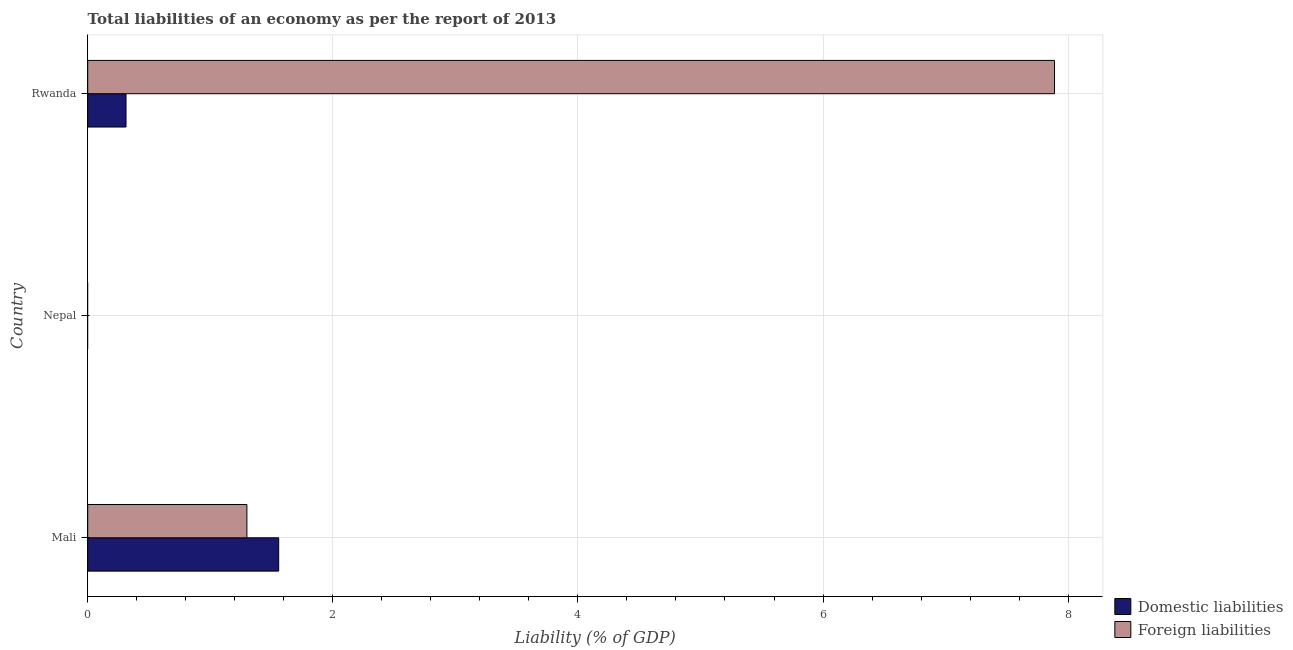How many different coloured bars are there?
Keep it short and to the point. 2. Are the number of bars per tick equal to the number of legend labels?
Offer a terse response. No. How many bars are there on the 2nd tick from the bottom?
Ensure brevity in your answer.  0. What is the label of the 3rd group of bars from the top?
Your response must be concise. Mali. In how many cases, is the number of bars for a given country not equal to the number of legend labels?
Offer a terse response. 1. What is the incurrence of domestic liabilities in Nepal?
Give a very brief answer. 0. Across all countries, what is the maximum incurrence of foreign liabilities?
Give a very brief answer. 7.89. In which country was the incurrence of foreign liabilities maximum?
Provide a short and direct response. Rwanda. What is the total incurrence of foreign liabilities in the graph?
Offer a terse response. 9.19. What is the difference between the incurrence of foreign liabilities in Mali and that in Rwanda?
Provide a short and direct response. -6.59. What is the difference between the incurrence of domestic liabilities in Rwanda and the incurrence of foreign liabilities in Nepal?
Keep it short and to the point. 0.31. What is the average incurrence of foreign liabilities per country?
Offer a very short reply. 3.06. What is the difference between the incurrence of domestic liabilities and incurrence of foreign liabilities in Rwanda?
Keep it short and to the point. -7.58. What is the ratio of the incurrence of domestic liabilities in Mali to that in Rwanda?
Give a very brief answer. 4.99. What is the difference between the highest and the lowest incurrence of foreign liabilities?
Offer a terse response. 7.89. In how many countries, is the incurrence of domestic liabilities greater than the average incurrence of domestic liabilities taken over all countries?
Your answer should be compact. 1. Is the sum of the incurrence of foreign liabilities in Mali and Rwanda greater than the maximum incurrence of domestic liabilities across all countries?
Ensure brevity in your answer.  Yes. How many bars are there?
Keep it short and to the point. 4. What is the difference between two consecutive major ticks on the X-axis?
Keep it short and to the point. 2. Does the graph contain any zero values?
Offer a terse response. Yes. Does the graph contain grids?
Provide a succinct answer. Yes. How many legend labels are there?
Your answer should be compact. 2. How are the legend labels stacked?
Make the answer very short. Vertical. What is the title of the graph?
Provide a short and direct response. Total liabilities of an economy as per the report of 2013. What is the label or title of the X-axis?
Your response must be concise. Liability (% of GDP). What is the Liability (% of GDP) of Domestic liabilities in Mali?
Offer a very short reply. 1.56. What is the Liability (% of GDP) in Foreign liabilities in Mali?
Provide a succinct answer. 1.3. What is the Liability (% of GDP) of Domestic liabilities in Nepal?
Your answer should be very brief. 0. What is the Liability (% of GDP) in Foreign liabilities in Nepal?
Keep it short and to the point. 0. What is the Liability (% of GDP) of Domestic liabilities in Rwanda?
Your response must be concise. 0.31. What is the Liability (% of GDP) of Foreign liabilities in Rwanda?
Your answer should be compact. 7.89. Across all countries, what is the maximum Liability (% of GDP) of Domestic liabilities?
Give a very brief answer. 1.56. Across all countries, what is the maximum Liability (% of GDP) of Foreign liabilities?
Keep it short and to the point. 7.89. Across all countries, what is the minimum Liability (% of GDP) of Domestic liabilities?
Make the answer very short. 0. What is the total Liability (% of GDP) of Domestic liabilities in the graph?
Give a very brief answer. 1.87. What is the total Liability (% of GDP) of Foreign liabilities in the graph?
Keep it short and to the point. 9.19. What is the difference between the Liability (% of GDP) of Domestic liabilities in Mali and that in Rwanda?
Offer a very short reply. 1.25. What is the difference between the Liability (% of GDP) of Foreign liabilities in Mali and that in Rwanda?
Provide a short and direct response. -6.59. What is the difference between the Liability (% of GDP) in Domestic liabilities in Mali and the Liability (% of GDP) in Foreign liabilities in Rwanda?
Your response must be concise. -6.33. What is the average Liability (% of GDP) of Domestic liabilities per country?
Your answer should be very brief. 0.62. What is the average Liability (% of GDP) in Foreign liabilities per country?
Provide a short and direct response. 3.06. What is the difference between the Liability (% of GDP) in Domestic liabilities and Liability (% of GDP) in Foreign liabilities in Mali?
Provide a short and direct response. 0.26. What is the difference between the Liability (% of GDP) of Domestic liabilities and Liability (% of GDP) of Foreign liabilities in Rwanda?
Offer a very short reply. -7.58. What is the ratio of the Liability (% of GDP) of Domestic liabilities in Mali to that in Rwanda?
Ensure brevity in your answer.  4.99. What is the ratio of the Liability (% of GDP) in Foreign liabilities in Mali to that in Rwanda?
Your response must be concise. 0.16. What is the difference between the highest and the lowest Liability (% of GDP) of Domestic liabilities?
Give a very brief answer. 1.56. What is the difference between the highest and the lowest Liability (% of GDP) of Foreign liabilities?
Make the answer very short. 7.89. 